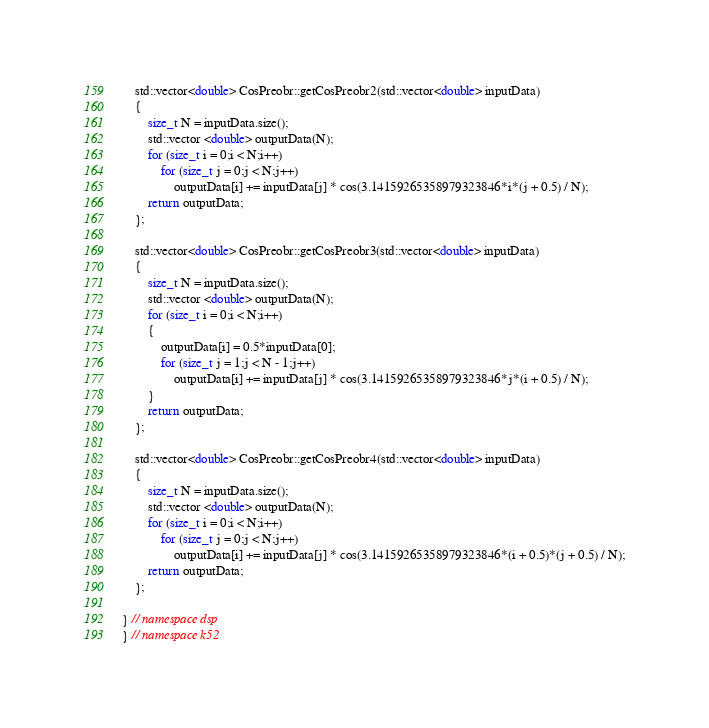Convert code to text. <code><loc_0><loc_0><loc_500><loc_500><_C++_>	std::vector<double> CosPreobr::getCosPreobr2(std::vector<double> inputData)
	{
		size_t N = inputData.size();
		std::vector <double> outputData(N);
		for (size_t i = 0;i < N;i++)
			for (size_t j = 0;j < N;j++)
				outputData[i] += inputData[j] * cos(3.14159265358979323846*i*(j + 0.5) / N);
		return outputData;
	};

	std::vector<double> CosPreobr::getCosPreobr3(std::vector<double> inputData)
	{
		size_t N = inputData.size();
		std::vector <double> outputData(N);
		for (size_t i = 0;i < N;i++)
		{
			outputData[i] = 0.5*inputData[0];
			for (size_t j = 1;j < N - 1;j++)
				outputData[i] += inputData[j] * cos(3.14159265358979323846*j*(i + 0.5) / N);
		}
		return outputData;
	};

	std::vector<double> CosPreobr::getCosPreobr4(std::vector<double> inputData)
	{
		size_t N = inputData.size();
		std::vector <double> outputData(N);
		for (size_t i = 0;i < N;i++)
			for (size_t j = 0;j < N;j++)
				outputData[i] += inputData[j] * cos(3.14159265358979323846*(i + 0.5)*(j + 0.5) / N);
		return outputData;
	};

} // namespace dsp
} // namespace k52
</code> 